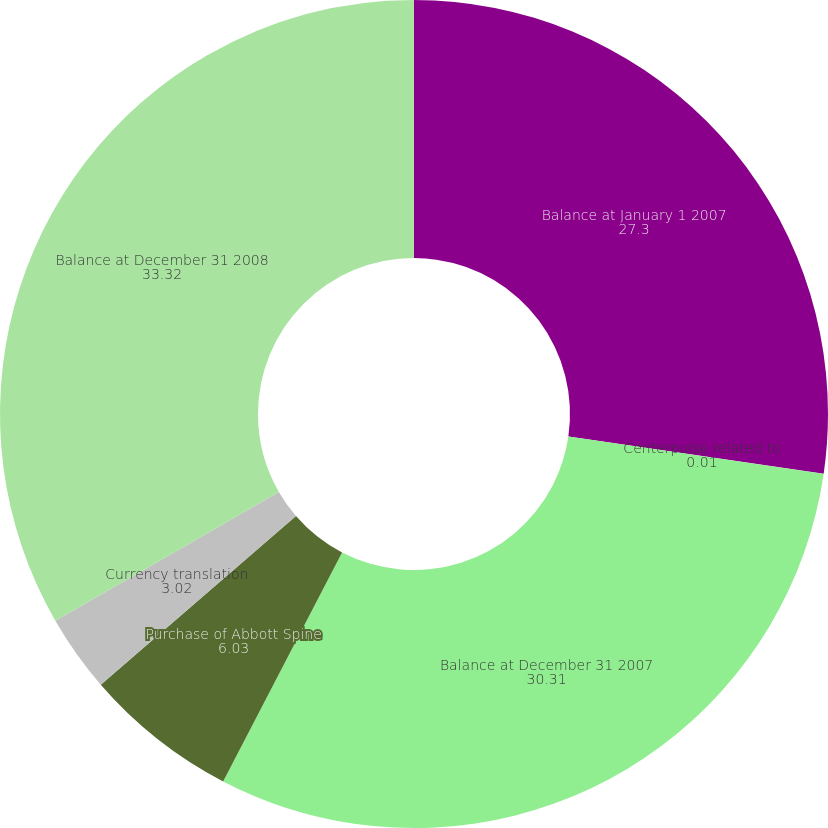<chart> <loc_0><loc_0><loc_500><loc_500><pie_chart><fcel>Balance at January 1 2007<fcel>Centerpulse related to<fcel>Balance at December 31 2007<fcel>Purchase of Abbott Spine<fcel>Currency translation<fcel>Balance at December 31 2008<nl><fcel>27.3%<fcel>0.01%<fcel>30.31%<fcel>6.03%<fcel>3.02%<fcel>33.32%<nl></chart> 